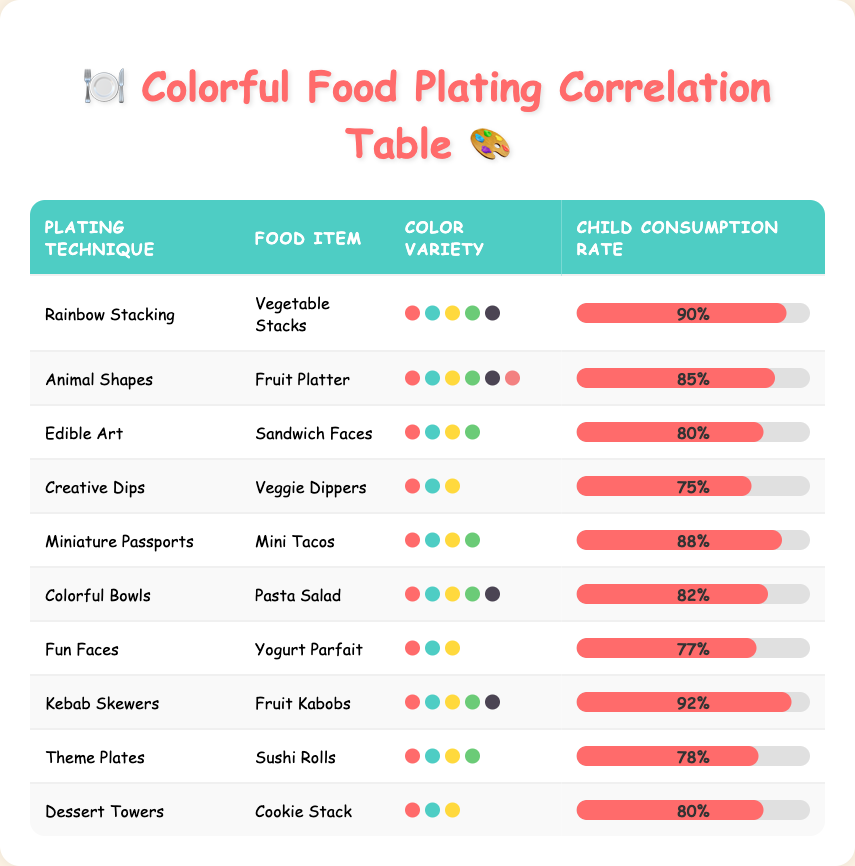What plating technique had the highest child consumption rate? By examining the child consumption rates listed in the table, we see that "Kebab Skewers" has the highest rate, which is 92%.
Answer: Kebab Skewers How many color varieties are found in the "Animal Shapes" plating technique? The "Animal Shapes" entry indicates a color variety of 6.
Answer: 6 What is the average child consumption rate for all listed plating techniques? To find the average, we sum the consumption rates: 90 + 85 + 80 + 75 + 88 + 82 + 77 + 92 + 78 + 80 =  817. Then, we divide by the number of techniques (10): 817/10 = 81.7.
Answer: 81.7 Is the child consumption rate for "Creative Dips" higher than that of "Fun Faces"? The rate for "Creative Dips" is 75%, while for "Fun Faces" it is 77%. Since 75% is not higher than 77%, the answer is no.
Answer: No Which plating technique has the lowest child consumption rate? Looking at the consumption rates, "Creative Dips" has the lowest rate of 75%.
Answer: Creative Dips What is the difference in child consumption rate between the "Rainbow Stacking" and "Theme Plates"? "Rainbow Stacking" has a rate of 90% and "Theme Plates" has a rate of 78%. The difference is 90 - 78 = 12%.
Answer: 12% How many plating techniques have a child consumption rate above 80%? We can see that "Rainbow Stacking" (90%), "Kebab Skewers" (92%), "Miniature Passports" (88%), and "Animal Shapes" (85%) are the only techniques with rates above 80%. This totals four techniques.
Answer: 4 What percentage of foods with 4 color varieties have a consumption rate of at least 80%? There are 3 plating techniques with 4 color varieties: "Edible Art" (80%), "Miniature Passports" (88%), and "Theme Plates" (78%). Two of these have rates above 80% (Edible Art and Miniature Passports). Therefore, the percentage is (2/3) * 100 = 66.67%.
Answer: 66.67% Are all food items listed in the table unique? By analyzing the food items listed, each item appears only once, confirming that all are unique.
Answer: Yes 